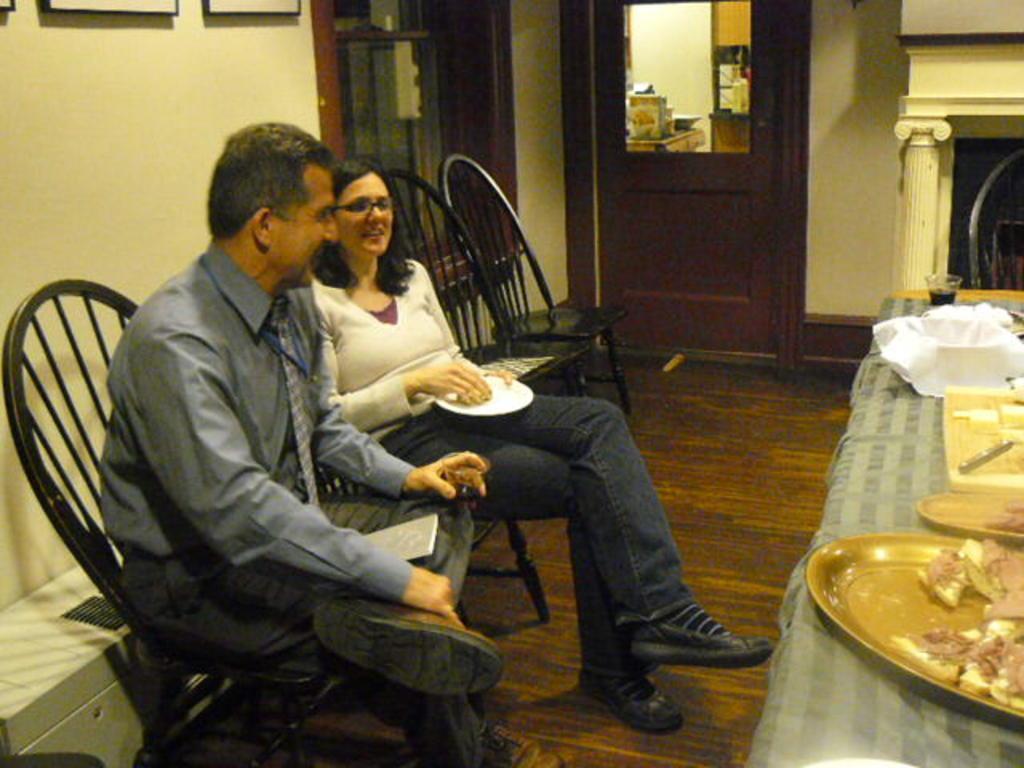In one or two sentences, can you explain what this image depicts? There is a man in gray color shirt, smiling and sitting on a chair, near a woman in white color t-shirt, holding a white color plate, smiling and sitting on another chair which is on the wooden floor. In front of them, there is a table, on which, there are food items on the plates and other objects. In the background, there are photo frames on the wall, there is a door, through this door, we can see, there are other objects. 